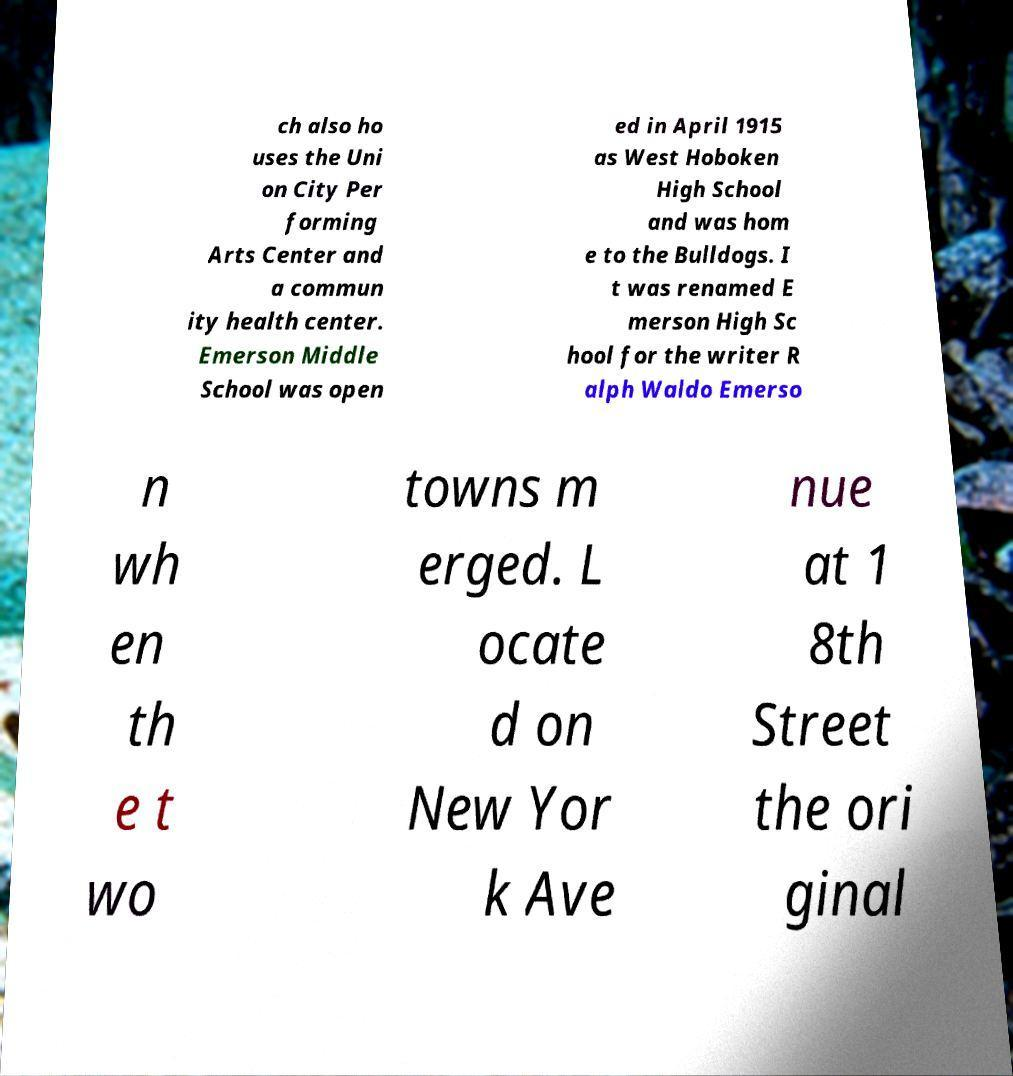Could you assist in decoding the text presented in this image and type it out clearly? ch also ho uses the Uni on City Per forming Arts Center and a commun ity health center. Emerson Middle School was open ed in April 1915 as West Hoboken High School and was hom e to the Bulldogs. I t was renamed E merson High Sc hool for the writer R alph Waldo Emerso n wh en th e t wo towns m erged. L ocate d on New Yor k Ave nue at 1 8th Street the ori ginal 